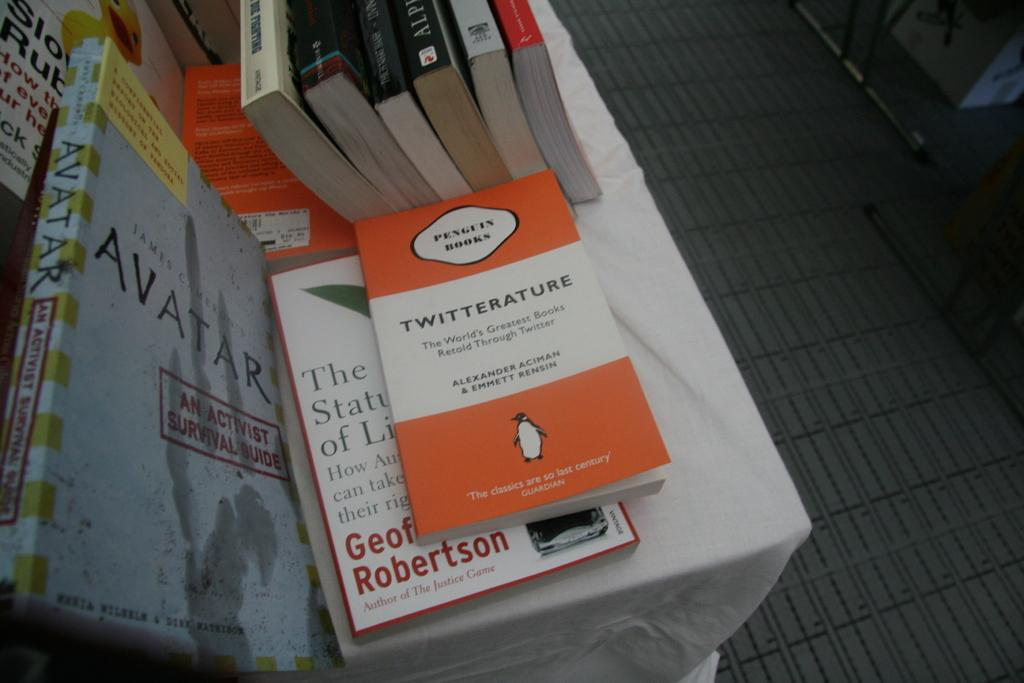Provide a one-sentence caption for the provided image. A copy of Twitterature from Penguin Books sits atop another book next to Avatar. 